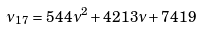<formula> <loc_0><loc_0><loc_500><loc_500>\nu _ { 1 7 } = 5 4 4 \nu ^ { 2 } + 4 2 1 3 \nu + 7 4 1 9</formula> 